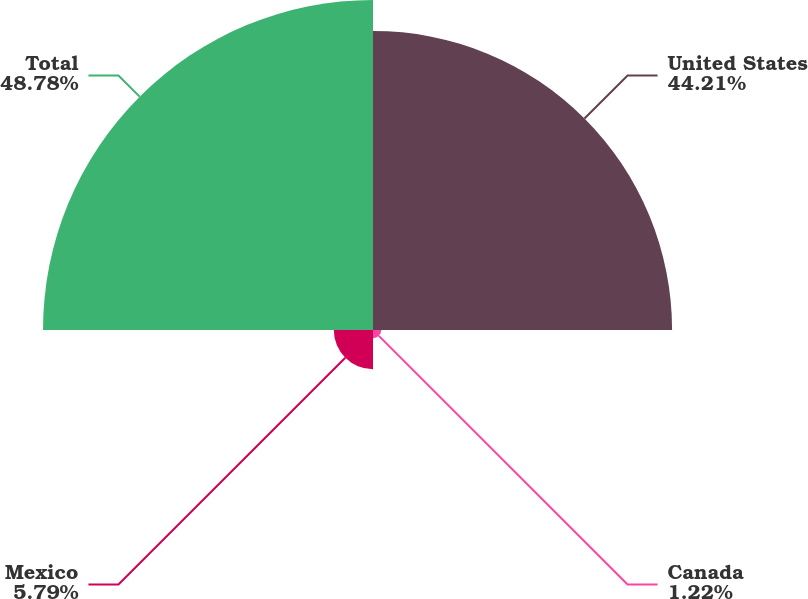<chart> <loc_0><loc_0><loc_500><loc_500><pie_chart><fcel>United States<fcel>Canada<fcel>Mexico<fcel>Total<nl><fcel>44.21%<fcel>1.22%<fcel>5.79%<fcel>48.78%<nl></chart> 